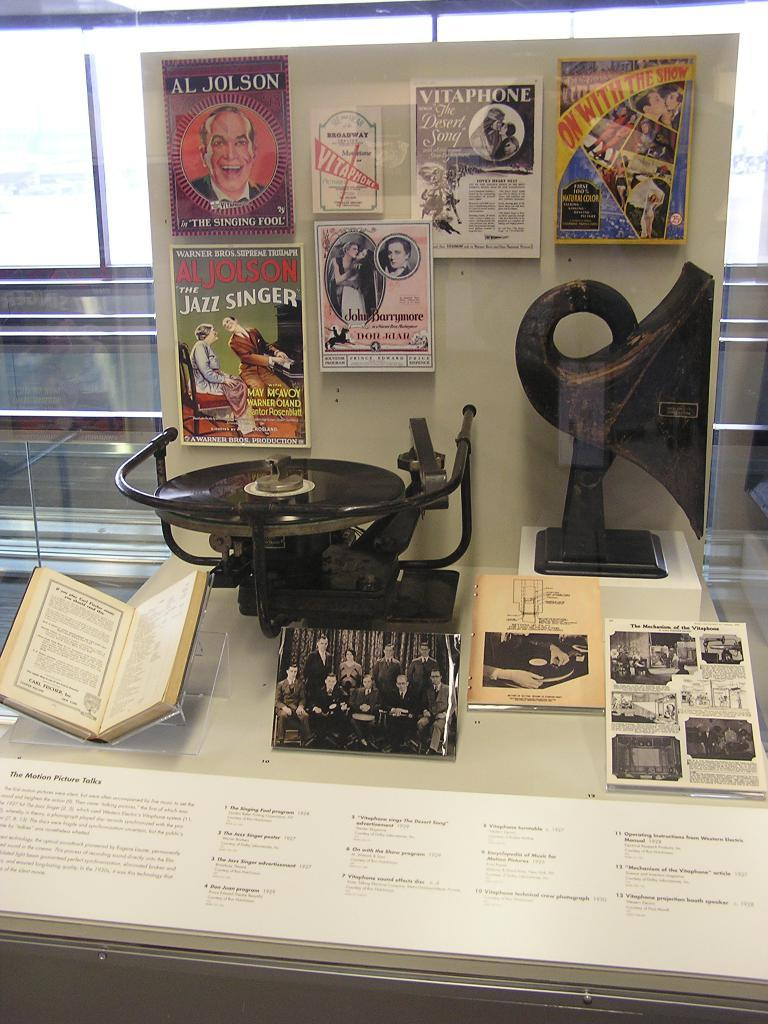<image>
Relay a brief, clear account of the picture shown. A display about The Motion Picture Talks with a display sign. 